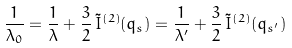<formula> <loc_0><loc_0><loc_500><loc_500>\frac { 1 } { \lambda _ { 0 } } = \frac { 1 } { \lambda } + \frac { 3 } { 2 } \, \tilde { I } ^ { ( 2 ) } ( q _ { s } ) = \frac { 1 } { \lambda ^ { \prime } } + \frac { 3 } { 2 } \, \tilde { I } ^ { ( 2 ) } ( q _ { s ^ { \prime } } )</formula> 